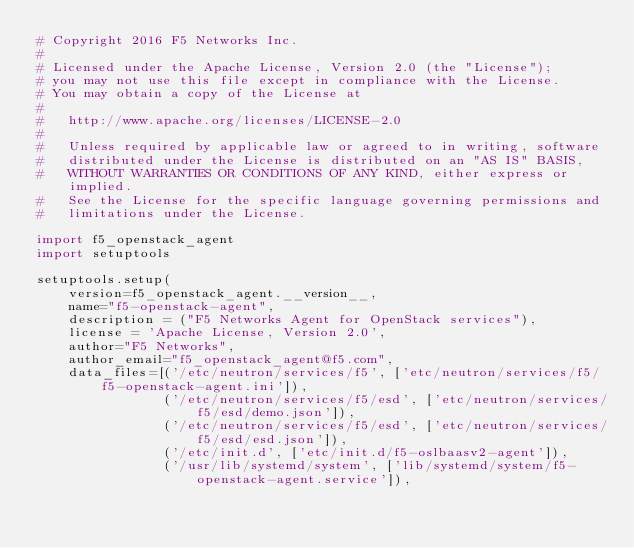Convert code to text. <code><loc_0><loc_0><loc_500><loc_500><_Python_># Copyright 2016 F5 Networks Inc.
#
# Licensed under the Apache License, Version 2.0 (the "License");
# you may not use this file except in compliance with the License.
# You may obtain a copy of the License at
#
#   http://www.apache.org/licenses/LICENSE-2.0
#
#   Unless required by applicable law or agreed to in writing, software
#   distributed under the License is distributed on an "AS IS" BASIS,
#   WITHOUT WARRANTIES OR CONDITIONS OF ANY KIND, either express or implied.
#   See the License for the specific language governing permissions and
#   limitations under the License.

import f5_openstack_agent
import setuptools

setuptools.setup(
    version=f5_openstack_agent.__version__,
    name="f5-openstack-agent",
    description = ("F5 Networks Agent for OpenStack services"),
    license = 'Apache License, Version 2.0',
    author="F5 Networks",
    author_email="f5_openstack_agent@f5.com",
    data_files=[('/etc/neutron/services/f5', ['etc/neutron/services/f5/f5-openstack-agent.ini']),
                ('/etc/neutron/services/f5/esd', ['etc/neutron/services/f5/esd/demo.json']),
                ('/etc/neutron/services/f5/esd', ['etc/neutron/services/f5/esd/esd.json']),
                ('/etc/init.d', ['etc/init.d/f5-oslbaasv2-agent']),
                ('/usr/lib/systemd/system', ['lib/systemd/system/f5-openstack-agent.service']),</code> 